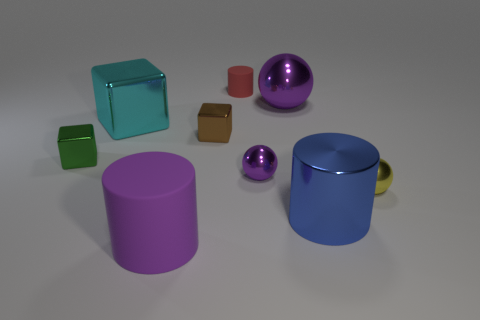Add 1 small brown metal objects. How many objects exist? 10 Subtract all tiny yellow balls. How many balls are left? 2 Subtract 1 balls. How many balls are left? 2 Add 6 big objects. How many big objects exist? 10 Subtract all cyan blocks. How many blocks are left? 2 Subtract 0 red balls. How many objects are left? 9 Subtract all blue cylinders. Subtract all yellow blocks. How many cylinders are left? 2 Subtract all yellow spheres. How many yellow cylinders are left? 0 Subtract all small cyan rubber cylinders. Subtract all small yellow balls. How many objects are left? 8 Add 8 metallic cylinders. How many metallic cylinders are left? 9 